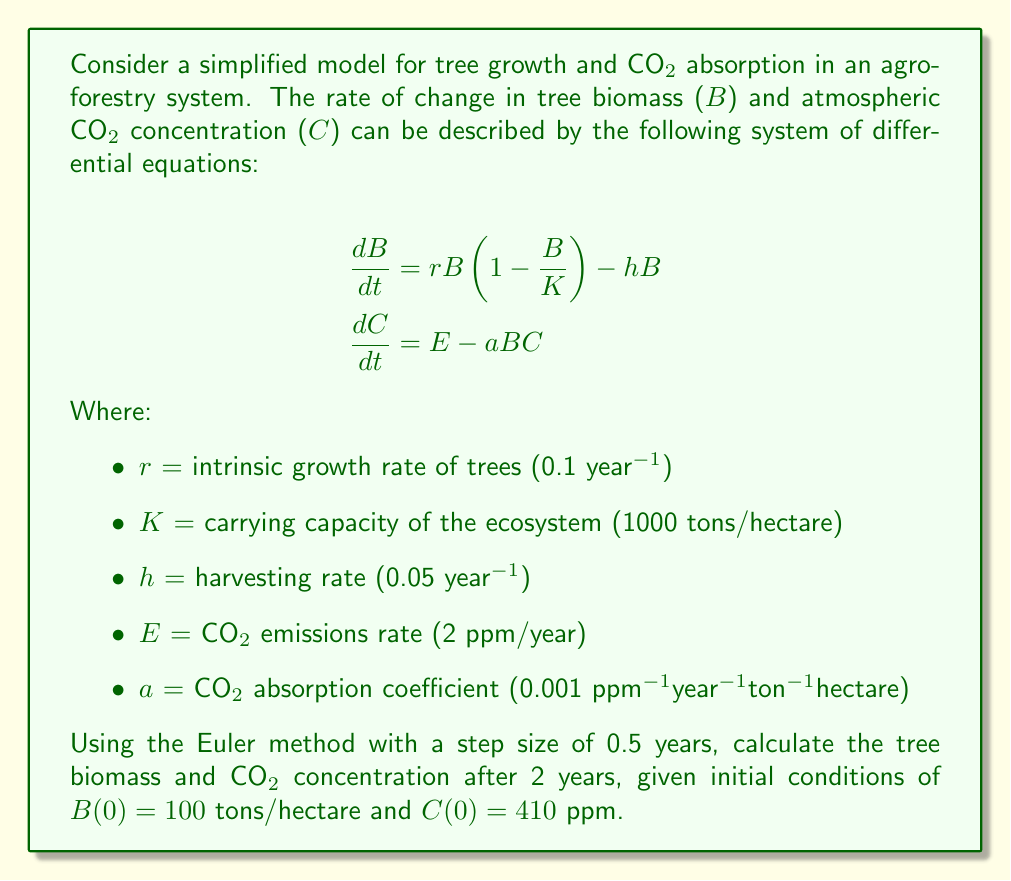Can you answer this question? To solve this system of differential equations using the Euler method, we follow these steps:

1) The Euler method is given by:
   $$y_{n+1} = y_n + h \cdot f(t_n, y_n)$$
   where $h$ is the step size and $f(t_n, y_n)$ is the right-hand side of the differential equation.

2) For our system, we have two equations:
   $$f_1(B,C) = rB(1 - \frac{B}{K}) - hB$$
   $$f_2(B,C) = E - aBC$$

3) We'll use a step size of $h = 0.5$ years and calculate for 4 steps to reach 2 years.

4) Starting values: $B_0 = 100$, $C_0 = 410$

5) Calculate for each step:

   Step 1 ($t = 0.5$):
   $$B_1 = B_0 + 0.5 \cdot [0.1 \cdot 100 \cdot (1 - \frac{100}{1000}) - 0.05 \cdot 100] = 102.25$$
   $$C_1 = C_0 + 0.5 \cdot [2 - 0.001 \cdot 100 \cdot 410] = 409.475$$

   Step 2 ($t = 1.0$):
   $$B_2 = 102.25 + 0.5 \cdot [0.1 \cdot 102.25 \cdot (1 - \frac{102.25}{1000}) - 0.05 \cdot 102.25] = 104.4628125$$
   $$C_2 = 409.475 + 0.5 \cdot [2 - 0.001 \cdot 102.25 \cdot 409.475] = 408.9307031$$

   Step 3 ($t = 1.5$):
   $$B_3 = 104.4628125 + 0.5 \cdot [0.1 \cdot 104.4628125 \cdot (1 - \frac{104.4628125}{1000}) - 0.05 \cdot 104.4628125] = 106.6217581$$
   $$C_3 = 408.9307031 + 0.5 \cdot [2 - 0.001 \cdot 104.4628125 \cdot 408.9307031] = 408.3671892$$

   Step 4 ($t = 2.0$):
   $$B_4 = 106.6217581 + 0.5 \cdot [0.1 \cdot 106.6217581 \cdot (1 - \frac{106.6217581}{1000}) - 0.05 \cdot 106.6217581] = 108.7275899$$
   $$C_4 = 408.3671892 + 0.5 \cdot [2 - 0.001 \cdot 106.6217581 \cdot 408.3671892] = 407.7846378$$

6) Therefore, after 2 years:
   Tree biomass (B) ≈ 108.73 tons/hectare
   CO2 concentration (C) ≈ 407.78 ppm
Answer: B ≈ 108.73 tons/hectare, C ≈ 407.78 ppm 